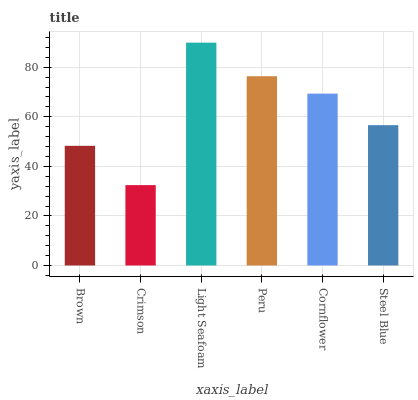Is Crimson the minimum?
Answer yes or no. Yes. Is Light Seafoam the maximum?
Answer yes or no. Yes. Is Light Seafoam the minimum?
Answer yes or no. No. Is Crimson the maximum?
Answer yes or no. No. Is Light Seafoam greater than Crimson?
Answer yes or no. Yes. Is Crimson less than Light Seafoam?
Answer yes or no. Yes. Is Crimson greater than Light Seafoam?
Answer yes or no. No. Is Light Seafoam less than Crimson?
Answer yes or no. No. Is Cornflower the high median?
Answer yes or no. Yes. Is Steel Blue the low median?
Answer yes or no. Yes. Is Steel Blue the high median?
Answer yes or no. No. Is Light Seafoam the low median?
Answer yes or no. No. 